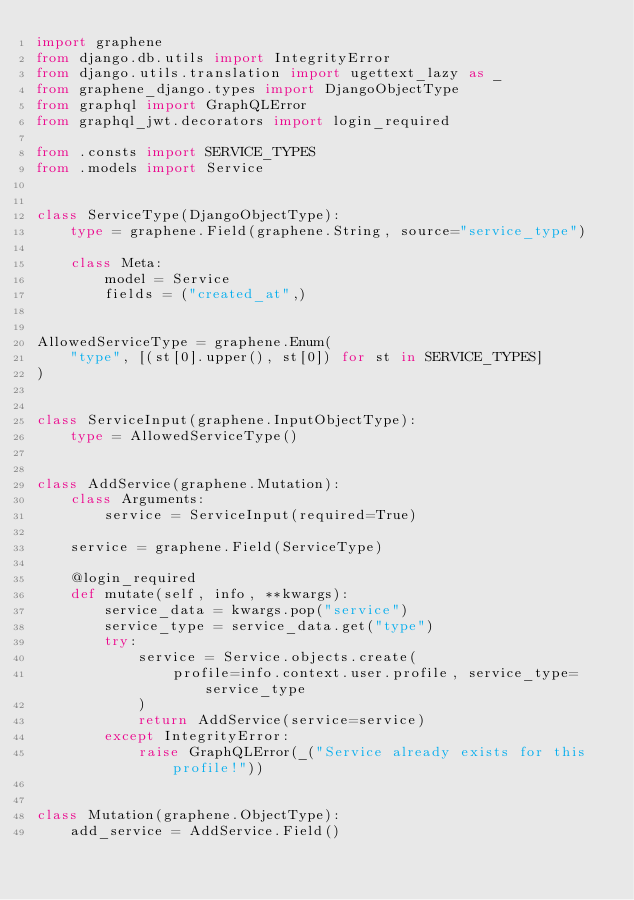Convert code to text. <code><loc_0><loc_0><loc_500><loc_500><_Python_>import graphene
from django.db.utils import IntegrityError
from django.utils.translation import ugettext_lazy as _
from graphene_django.types import DjangoObjectType
from graphql import GraphQLError
from graphql_jwt.decorators import login_required

from .consts import SERVICE_TYPES
from .models import Service


class ServiceType(DjangoObjectType):
    type = graphene.Field(graphene.String, source="service_type")

    class Meta:
        model = Service
        fields = ("created_at",)


AllowedServiceType = graphene.Enum(
    "type", [(st[0].upper(), st[0]) for st in SERVICE_TYPES]
)


class ServiceInput(graphene.InputObjectType):
    type = AllowedServiceType()


class AddService(graphene.Mutation):
    class Arguments:
        service = ServiceInput(required=True)

    service = graphene.Field(ServiceType)

    @login_required
    def mutate(self, info, **kwargs):
        service_data = kwargs.pop("service")
        service_type = service_data.get("type")
        try:
            service = Service.objects.create(
                profile=info.context.user.profile, service_type=service_type
            )
            return AddService(service=service)
        except IntegrityError:
            raise GraphQLError(_("Service already exists for this profile!"))


class Mutation(graphene.ObjectType):
    add_service = AddService.Field()
</code> 